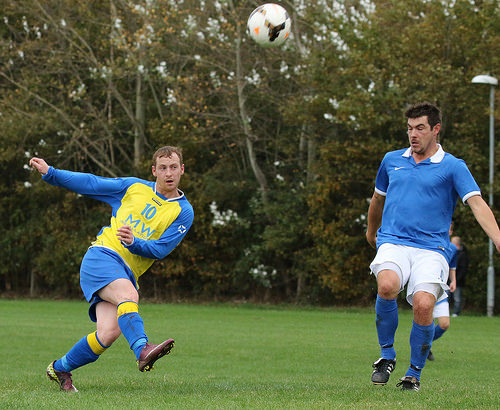<image>
Is the man to the left of the man? Yes. From this viewpoint, the man is positioned to the left side relative to the man. Where is the ball in relation to the man? Is it behind the man? No. The ball is not behind the man. From this viewpoint, the ball appears to be positioned elsewhere in the scene. 